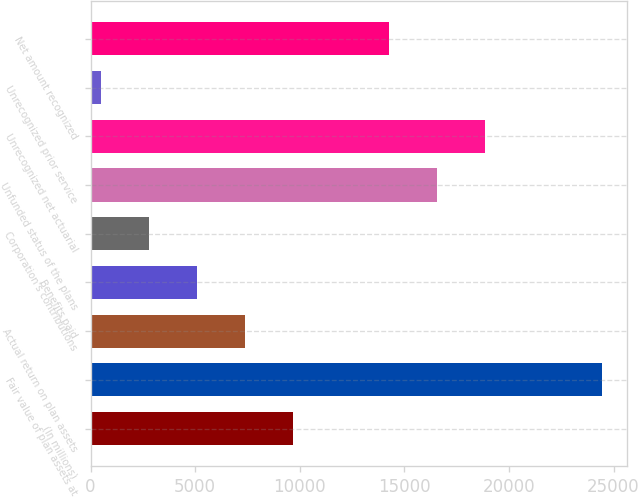Convert chart to OTSL. <chart><loc_0><loc_0><loc_500><loc_500><bar_chart><fcel>(In millions)<fcel>Fair value of plan assets at<fcel>Actual return on plan assets<fcel>Benefits paid<fcel>Corporation's contributions<fcel>Unfunded status of the plans<fcel>Unrecognized net actuarial<fcel>Unrecognized prior service<fcel>Net amount recognized<nl><fcel>9668<fcel>24433<fcel>7374<fcel>5080<fcel>2786<fcel>16550<fcel>18844<fcel>492<fcel>14256<nl></chart> 